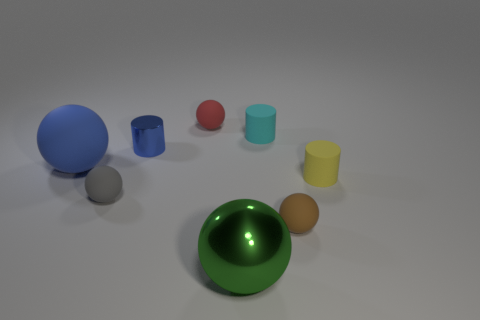There is a big thing that is to the right of the blue metal thing; is it the same shape as the tiny red thing that is on the left side of the brown matte thing?
Provide a succinct answer. Yes. How big is the rubber cylinder on the right side of the tiny ball in front of the tiny gray thing left of the tiny red object?
Your answer should be very brief. Small. What size is the red matte ball that is on the left side of the small cyan cylinder?
Keep it short and to the point. Small. What material is the big ball behind the tiny yellow rubber object?
Your response must be concise. Rubber. How many red things are either shiny cylinders or big spheres?
Make the answer very short. 0. Is the tiny blue cylinder made of the same material as the big object that is on the left side of the large shiny ball?
Your answer should be very brief. No. Are there the same number of yellow matte things that are in front of the brown matte object and small matte cylinders that are on the right side of the blue rubber object?
Offer a very short reply. No. There is a blue cylinder; is it the same size as the rubber thing behind the tiny cyan rubber cylinder?
Your answer should be compact. Yes. Are there more objects that are in front of the tiny brown object than brown cylinders?
Your answer should be very brief. Yes. What number of gray rubber spheres have the same size as the yellow rubber cylinder?
Give a very brief answer. 1. 